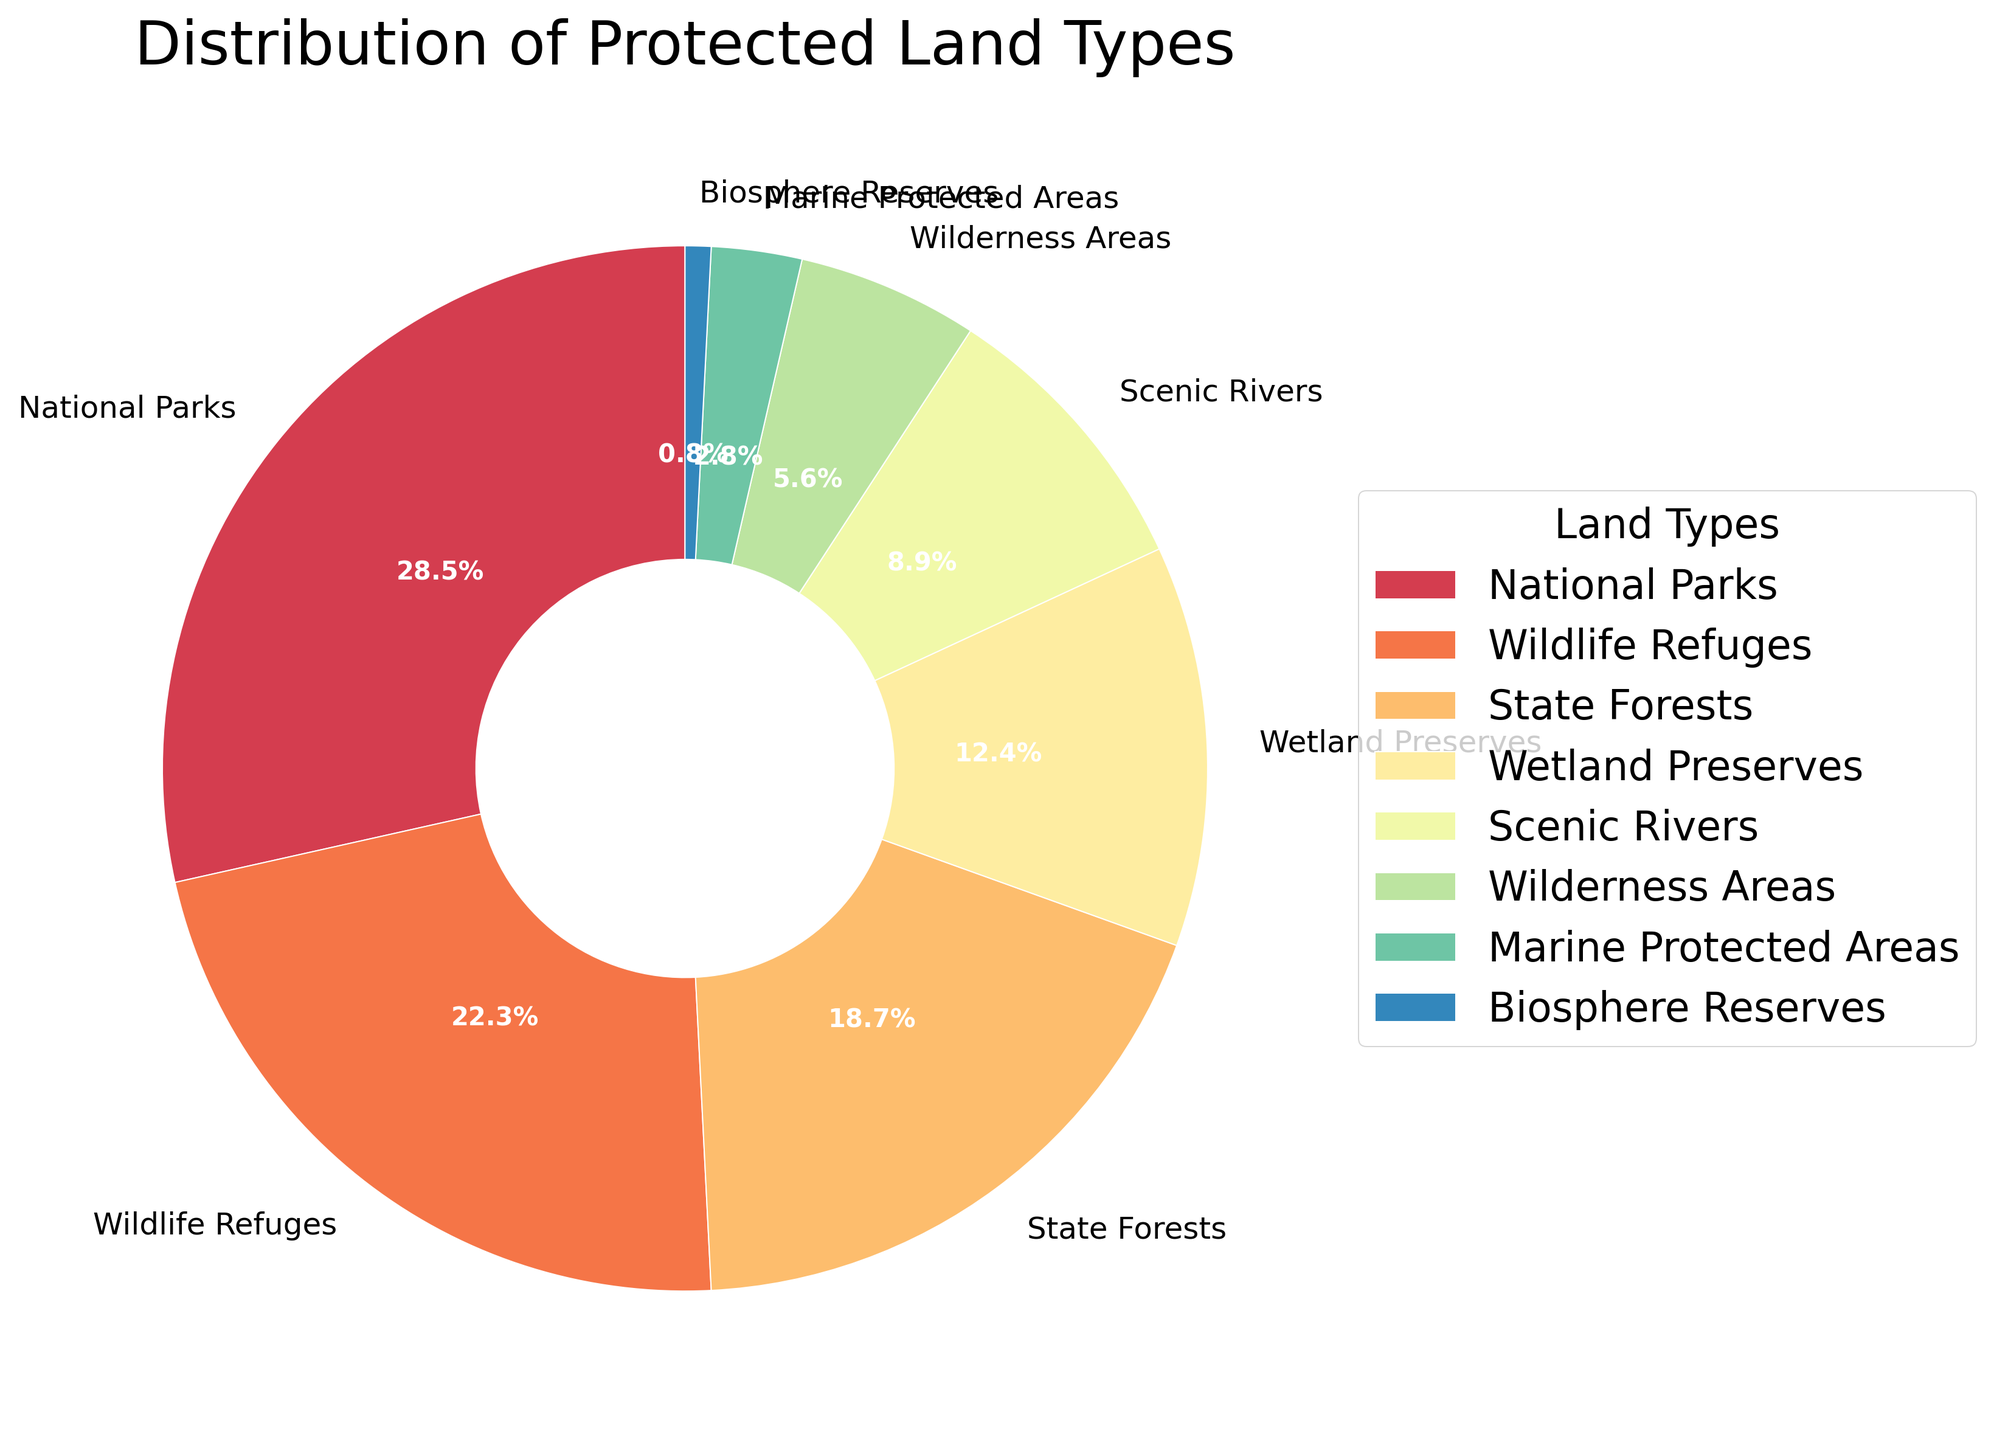Which protected land type occupies the largest percentage? The chart shows that the largest section is attributed to 'National Parks,' which has the highest percentage value among all the land types.
Answer: National Parks How much larger is the percentage of 'National Parks' than 'Wilderness Areas'? To find the difference, subtract the percentage of 'Wilderness Areas' (5.6%) from the percentage of 'National Parks' (28.5%). So, 28.5% - 5.6% = 22.9%.
Answer: 22.9% What is the combined percentage of 'Wildlife Refuges' and 'Scenic Rivers'? Add the percentage of 'Wildlife Refuges' (22.3%) and 'Scenic Rivers' (8.9%). So, 22.3% + 8.9% = 31.2%.
Answer: 31.2% Which land type covers the smallest area according to the pie chart? The smallest segment in the pie chart is labeled as 'Biosphere Reserves' with a percentage of 0.8%.
Answer: Biosphere Reserves Are there any protected land types that have a percentage below 10%? From the pie chart, the land types with percentages below 10% are 'Scenic Rivers' (8.9%), 'Wilderness Areas' (5.6%), 'Marine Protected Areas' (2.8%), and 'Biosphere Reserves' (0.8%).
Answer: Yes What percentage of the area is occupied by 'Marine Protected Areas' and 'Biosphere Reserves' together? Add the percentage of 'Marine Protected Areas' (2.8%) to 'Biosphere Reserves' (0.8%). So, 2.8% + 0.8% = 3.6%.
Answer: 3.6% Which land type is immediately adjacent (clockwise) to 'State Forests' in the pie chart? From the pie chart's order, 'Wetland Preserves' follows 'State Forests' in a clockwise direction.
Answer: Wetland Preserves How does the percentage of 'State Forests' compare to 'Wetland Preserves'? The chart shows that 'State Forests' have a percentage of 18.7% which is larger than 'Wetland Preserves' at 12.4%.
Answer: State Forests > Wetland Preserves What is the average percentage of 'National Parks', 'Wildlife Refuges', and 'State Forests'? Add the percentages of 'National Parks' (28.5%), 'Wildlife Refuges' (22.3%), and 'State Forests' (18.7%), then divide by three. So, the average is (28.5 + 22.3 + 18.7) / 3 = 23.17.
Answer: 23.2 (rounded) 